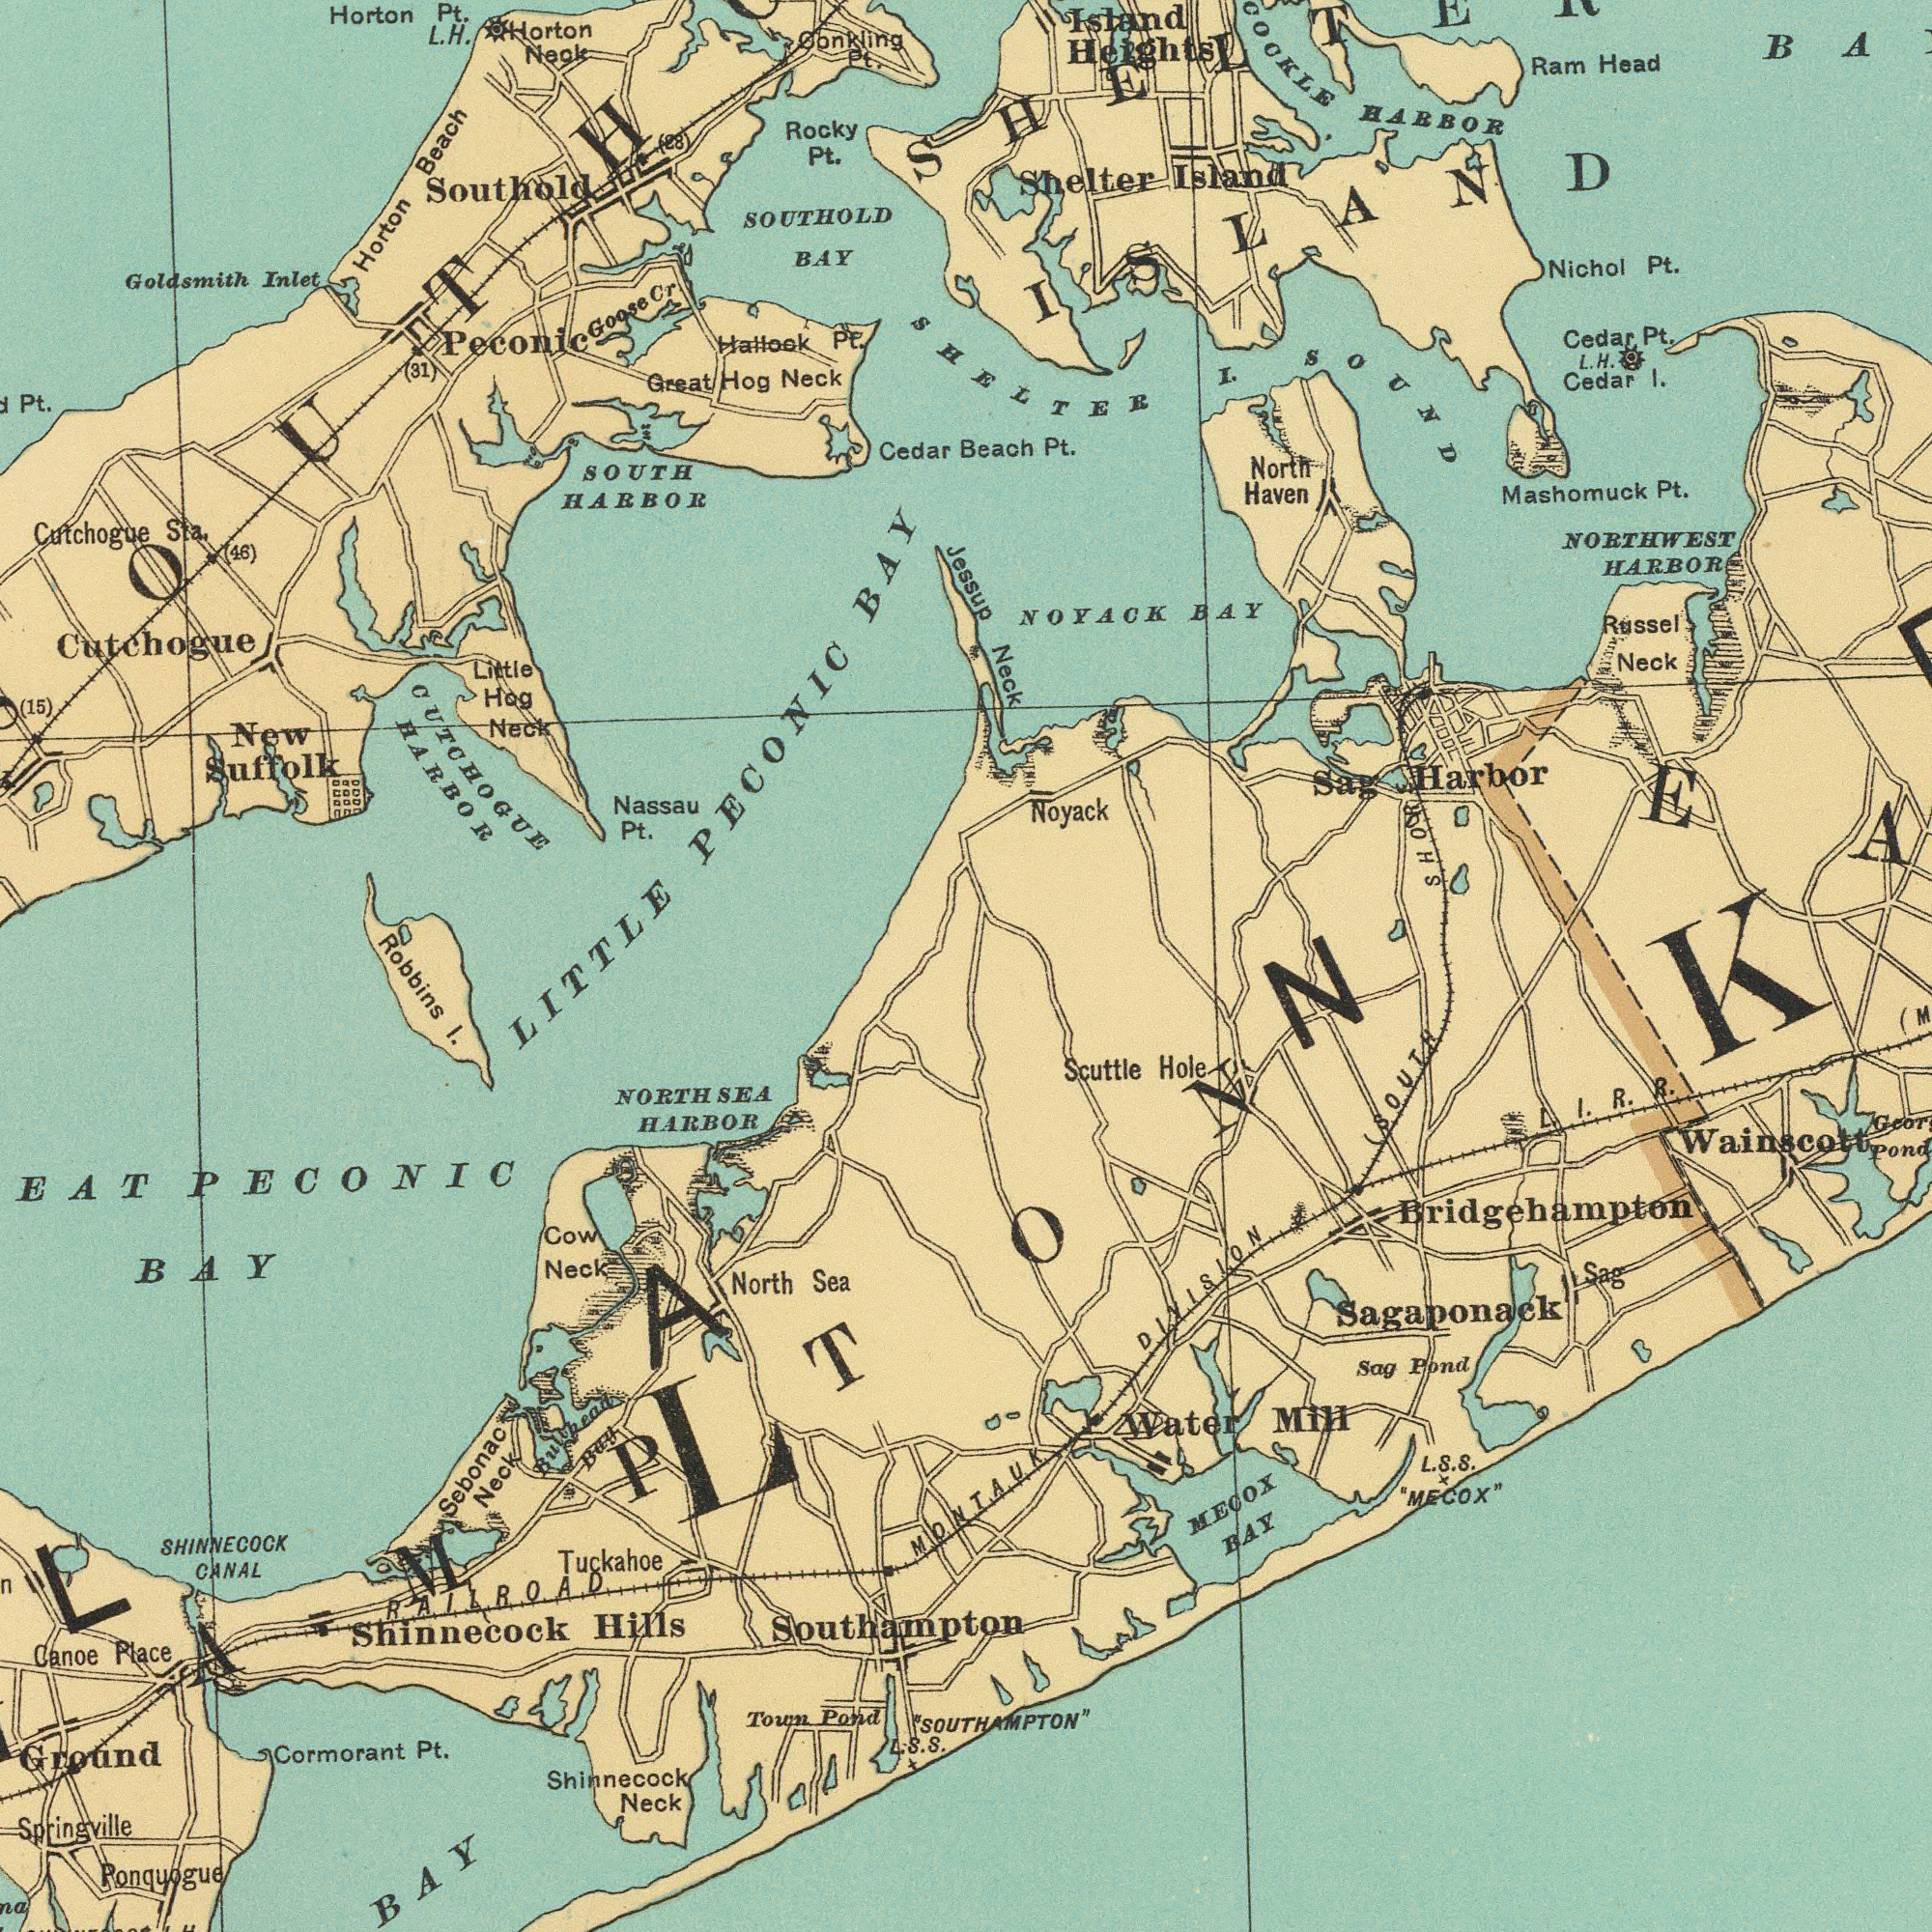What text is visible in the upper-right corner? Beach Pt. SHELTER I SOUND Island Heights Shelter Island HARBOR Nichol Pt. Noyack NORTHWEST HARBOR Ram Head Neck L. H. Cedar I. Sag Harbor Cedar Pt. Russel Neck North Haven NOYACK BAY Mashomuck Pt. SHORE) ISLAND What text can you see in the top-left section? Cutchogue Sta. SOUTHOLD BAY SOUTH HARBOR Cutchogue LITTLE PECONIC BAY Goldsmith Inlet New Suffolk Hallock Pt. Horton Beach Nassau Pt. Peconic Great Hog Neck Southold Cedar Horton Neok Pt. Little Hog Neck Rocky Pt. Horton Pt. L.H. (15) Goose Cr (31) onkling Pt. (46) CUTCHOGUE HARBOR (28) Jessup What text is visible in the lower-left corner? Springville EAT PECONIC BAY Ground NORTHSEA HARBOR Cormorant Pt. Shinnecock Neck Robbins I. Town Pond Cow Neck SHINNECOCK CANAL Ponquogue Shinnecock Hills Southampton North Sea Tuckahoe Sebonac Neck Canoe Place RAILROAD Bay S.S. BAY What text appears in the bottom-right area of the image? MONTAUK DIVISION "SOUTHAMPTON" (SOUTH MECOX BAY Scuttle Hole Water Mill L. S. S. MECOX" Bridgehampton Wainscott Sag Pond Sag Sagaponack L I. R. R. Pond ###LK### 